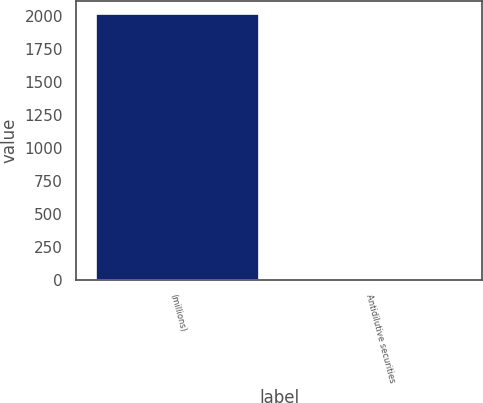Convert chart to OTSL. <chart><loc_0><loc_0><loc_500><loc_500><bar_chart><fcel>(millions)<fcel>Antidilutive securities<nl><fcel>2014<fcel>1.6<nl></chart> 